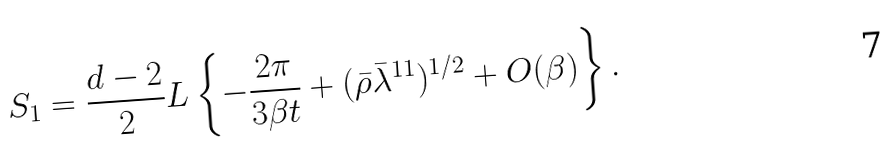Convert formula to latex. <formula><loc_0><loc_0><loc_500><loc_500>S _ { 1 } = \frac { d - 2 } { 2 } L \left \{ - \frac { 2 \pi } { 3 \beta t } + ( \bar { \rho } \bar { \lambda } ^ { 1 1 } ) ^ { 1 / 2 } + O ( \beta ) \right \} .</formula> 